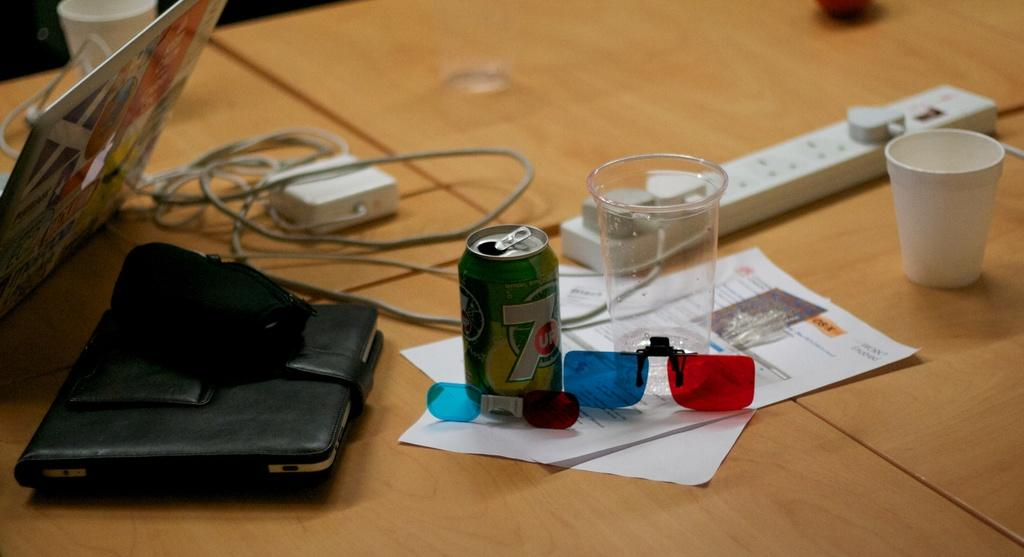What is the main object in the image? There is a tin in the image. What else can be seen in the image? There are glasses, devices, a laptop, papers, and a gadget in the image. Where are the glasses located in the image? The glasses are on a table in the image. What type of structure can be seen in the background of the image? There is no structure visible in the image. Can you see a ship in the image? There is no ship present in the image. 